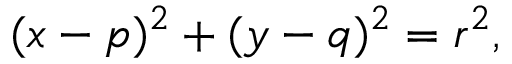<formula> <loc_0><loc_0><loc_500><loc_500>( x - p ) ^ { 2 } + ( y - q ) ^ { 2 } = r ^ { 2 } ,</formula> 